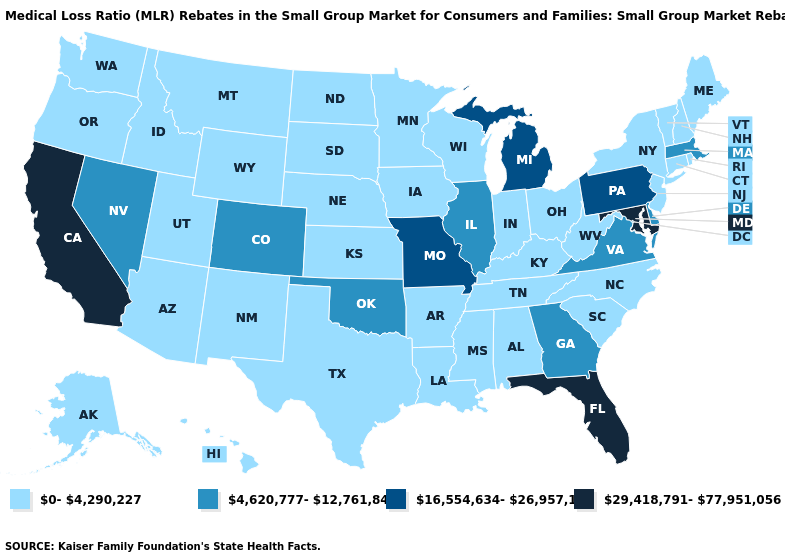What is the value of North Carolina?
Short answer required. 0-4,290,227. Does Nevada have the same value as Massachusetts?
Concise answer only. Yes. What is the lowest value in the Northeast?
Short answer required. 0-4,290,227. Which states have the lowest value in the West?
Give a very brief answer. Alaska, Arizona, Hawaii, Idaho, Montana, New Mexico, Oregon, Utah, Washington, Wyoming. Name the states that have a value in the range 16,554,634-26,957,163?
Be succinct. Michigan, Missouri, Pennsylvania. What is the value of Georgia?
Quick response, please. 4,620,777-12,761,841. What is the lowest value in the USA?
Answer briefly. 0-4,290,227. What is the lowest value in the MidWest?
Give a very brief answer. 0-4,290,227. Name the states that have a value in the range 29,418,791-77,951,056?
Short answer required. California, Florida, Maryland. Name the states that have a value in the range 29,418,791-77,951,056?
Keep it brief. California, Florida, Maryland. Which states have the lowest value in the USA?
Give a very brief answer. Alabama, Alaska, Arizona, Arkansas, Connecticut, Hawaii, Idaho, Indiana, Iowa, Kansas, Kentucky, Louisiana, Maine, Minnesota, Mississippi, Montana, Nebraska, New Hampshire, New Jersey, New Mexico, New York, North Carolina, North Dakota, Ohio, Oregon, Rhode Island, South Carolina, South Dakota, Tennessee, Texas, Utah, Vermont, Washington, West Virginia, Wisconsin, Wyoming. Does New Jersey have a lower value than West Virginia?
Answer briefly. No. Does the first symbol in the legend represent the smallest category?
Quick response, please. Yes. What is the highest value in states that border Massachusetts?
Short answer required. 0-4,290,227. 